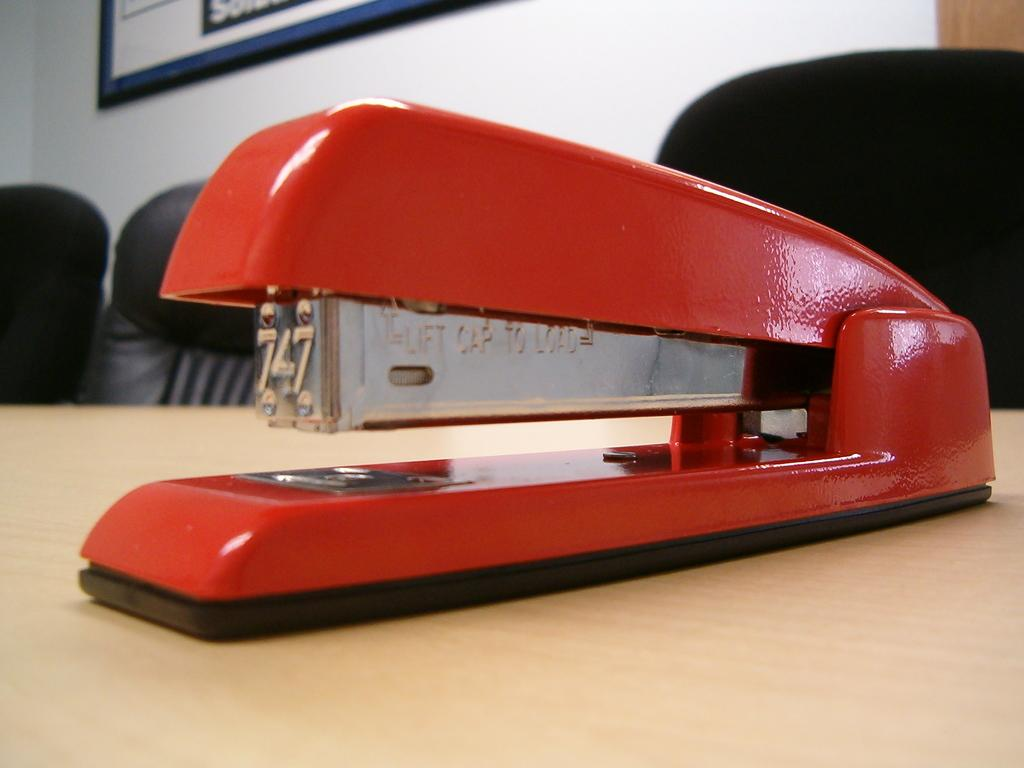What object is placed on the table in the image? There is a stapler on a table in the image. What can be seen in the background of the image? There are chairs in the background of the image. What is hanging on the wall in the image? There is a photo frame on the wall in the image. How many sticks are being used to advertise a product in the image? There are no sticks or advertisements present in the image. 